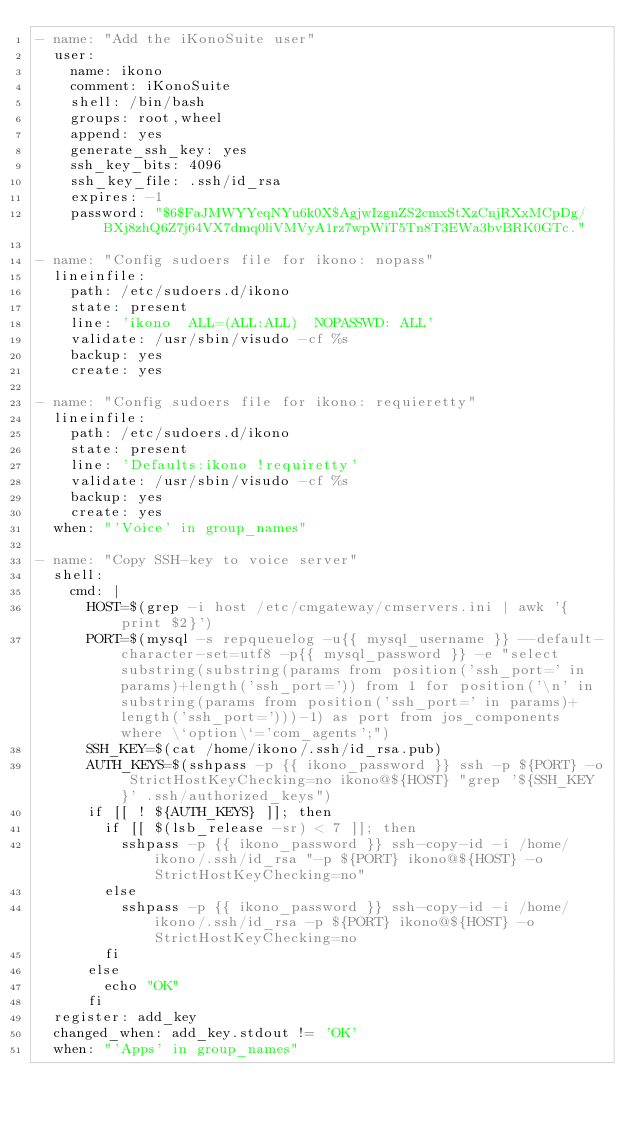<code> <loc_0><loc_0><loc_500><loc_500><_YAML_>- name: "Add the iKonoSuite user"
  user:
    name: ikono
    comment: iKonoSuite
    shell: /bin/bash
    groups: root,wheel
    append: yes
    generate_ssh_key: yes
    ssh_key_bits: 4096
    ssh_key_file: .ssh/id_rsa
    expires: -1
    password: "$6$FaJMWYYeqNYu6k0X$AgjwIzgnZS2cmxStXzCnjRXxMCpDg/BXj8zhQ6Z7j64VX7dmq0liVMVyA1rz7wpWiT5Tn8T3EWa3bvBRK0GTc."

- name: "Config sudoers file for ikono: nopass"
  lineinfile:
    path: /etc/sudoers.d/ikono
    state: present
    line: 'ikono  ALL=(ALL:ALL)  NOPASSWD: ALL'
    validate: /usr/sbin/visudo -cf %s
    backup: yes
    create: yes

- name: "Config sudoers file for ikono: requieretty"
  lineinfile:
    path: /etc/sudoers.d/ikono
    state: present
    line: 'Defaults:ikono !requiretty'
    validate: /usr/sbin/visudo -cf %s
    backup: yes
    create: yes
  when: "'Voice' in group_names"

- name: "Copy SSH-key to voice server"
  shell: 
    cmd: |
      HOST=$(grep -i host /etc/cmgateway/cmservers.ini | awk '{print $2}')
      PORT=$(mysql -s repqueuelog -u{{ mysql_username }} --default-character-set=utf8 -p{{ mysql_password }} -e "select substring(substring(params from position('ssh_port=' in params)+length('ssh_port=')) from 1 for position('\n' in substring(params from position('ssh_port=' in params)+length('ssh_port=')))-1) as port from jos_components where \`option\`='com_agents';")
      SSH_KEY=$(cat /home/ikono/.ssh/id_rsa.pub)
      AUTH_KEYS=$(sshpass -p {{ ikono_password }} ssh -p ${PORT} -o StrictHostKeyChecking=no ikono@${HOST} "grep '${SSH_KEY}' .ssh/authorized_keys")
      if [[ ! ${AUTH_KEYS} ]]; then 
        if [[ $(lsb_release -sr) < 7 ]]; then
          sshpass -p {{ ikono_password }} ssh-copy-id -i /home/ikono/.ssh/id_rsa "-p ${PORT} ikono@${HOST} -o StrictHostKeyChecking=no"
        else
          sshpass -p {{ ikono_password }} ssh-copy-id -i /home/ikono/.ssh/id_rsa -p ${PORT} ikono@${HOST} -o StrictHostKeyChecking=no
        fi
      else
        echo "OK"
      fi
  register: add_key
  changed_when: add_key.stdout != 'OK'
  when: "'Apps' in group_names"
</code> 